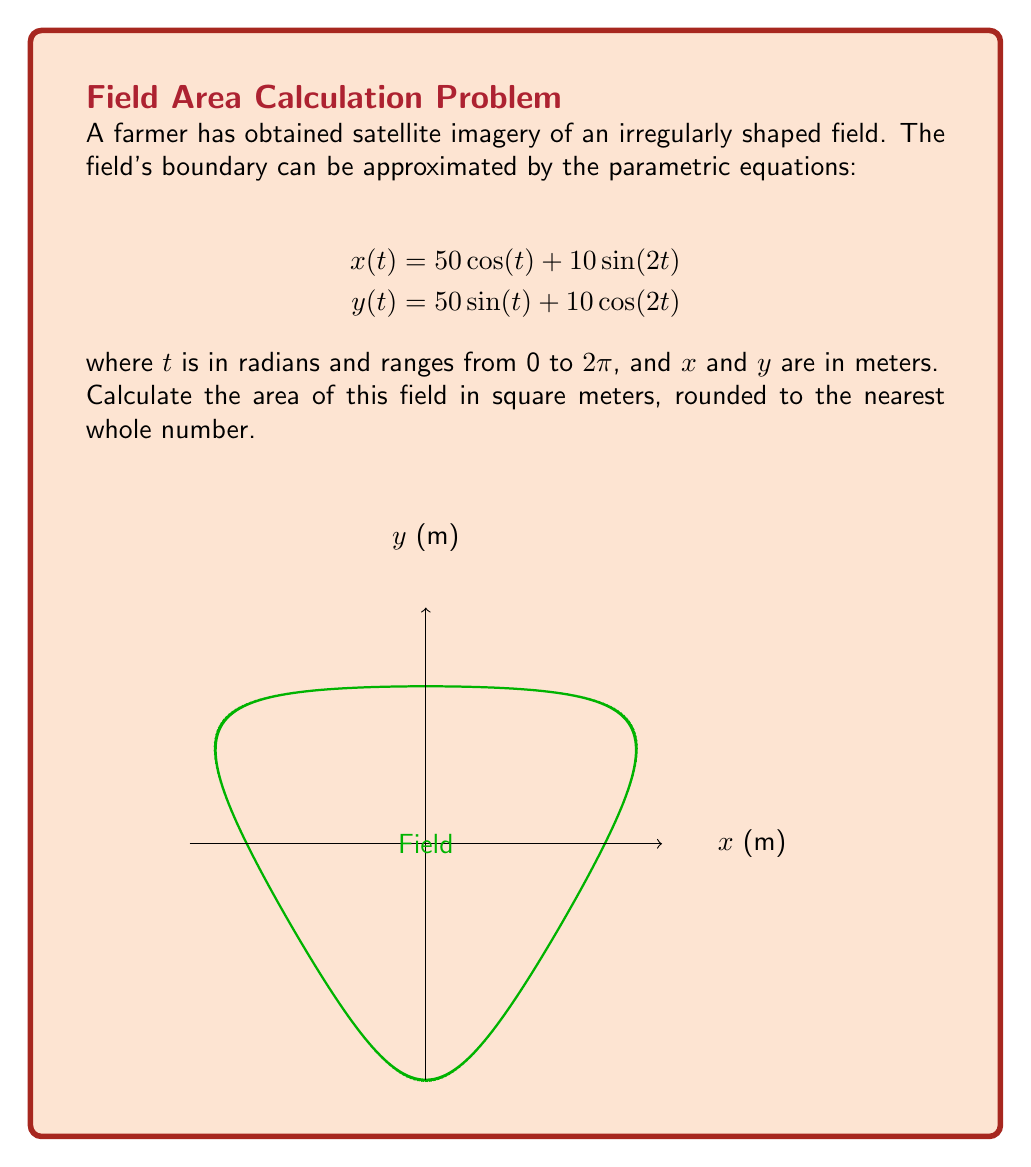Can you answer this question? To calculate the area enclosed by a parametric curve, we can use Green's theorem in the form:

$$\text{Area} = \frac{1}{2} \int_0^{2\pi} [x(t)y'(t) - y(t)x'(t)] dt$$

Step 1: Calculate $x'(t)$ and $y'(t)$
$$x'(t) = -50 \sin(t) + 20 \cos(2t)$$
$$y'(t) = 50 \cos(t) - 20 \sin(2t)$$

Step 2: Form the integrand $[x(t)y'(t) - y(t)x'(t)]$
$$(50 \cos(t) + 10 \sin(2t))(50 \cos(t) - 20 \sin(2t)) - (50 \sin(t) + 10 \cos(2t))(-50 \sin(t) + 20 \cos(2t))$$

Step 3: Expand and simplify the integrand
$$2500 \cos^2(t) - 1000 \cos(t)\sin(2t) + 500 \sin(t)\cos(t) + 200 \sin(t)\cos(2t) + 2500 \sin^2(t) - 1000 \sin(t)\cos(2t)$$
$$= 2500 (\cos^2(t) + \sin^2(t)) + 500 \sin(2t) - 1000 \cos(t)\sin(2t) - 800 \sin(t)\cos(2t)$$
$$= 2500 + 500 \sin(2t) - 1000 \cos(t)\sin(2t) - 800 \sin(t)\cos(2t)$$

Step 4: Integrate from 0 to $2\pi$
$$\text{Area} = \frac{1}{2} \int_0^{2\pi} [2500 + 500 \sin(2t) - 1000 \cos(t)\sin(2t) - 800 \sin(t)\cos(2t)] dt$$

The integrals of $\sin(2t)$, $\cos(t)\sin(2t)$, and $\sin(t)\cos(2t)$ over a full period are all zero, so we're left with:

$$\text{Area} = \frac{1}{2} \int_0^{2\pi} 2500 dt = \frac{1}{2} \cdot 2500 \cdot 2\pi = 2500\pi$$

Step 5: Round to the nearest whole number
$$2500\pi \approx 7854$$

Therefore, the area of the field is approximately 7854 square meters.
Answer: 7854 square meters 